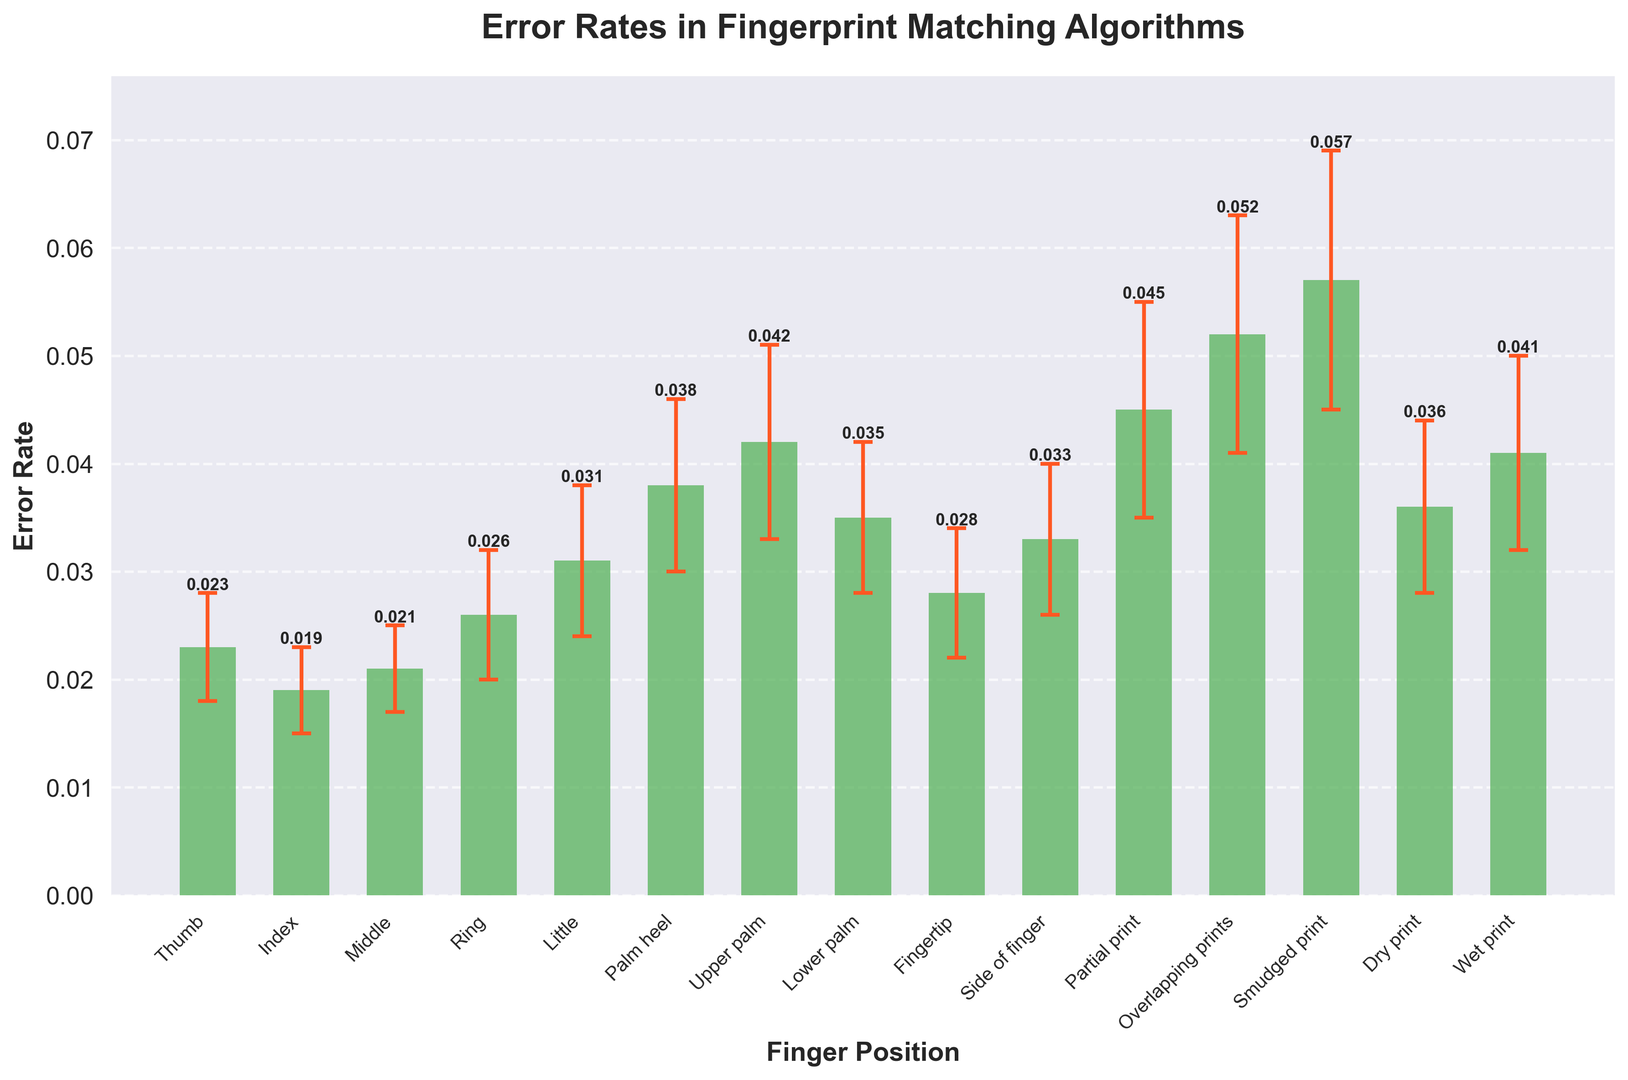Which finger position has the highest error rate? By observing the heights of the bars in the chart, the "Smudged print" bar is the tallest, indicating the highest error rate.
Answer: Smudged print What is the difference in error rate between "Thumb" and "Little" finger positions? The error rate for "Thumb" is 0.023 and for "Little" is 0.031. The difference is calculated as 0.031 - 0.023.
Answer: 0.008 Which finger position has the lowest error rate, and what is its value? By examining the chart, the shortest bar represents the "Index" finger position with an error rate of 0.019.
Answer: Index, 0.019 How much higher is the error rate for "Overlapping prints" compared to "Lower palm"? The error rate for "Overlapping prints" is 0.052 and for "Lower palm" is 0.035. Subtract the error rate of "Lower palm" from "Overlapping prints".
Answer: 0.017 What is the average error rate for the "Thumb", "Index", and "Middle" finger positions? Add the error rates of "Thumb" (0.023), "Index" (0.019), and "Middle" (0.021) and divide by 3: (0.023 + 0.019 + 0.021) / 3.
Answer: 0.021 Which finger positions have error margins greater than or equal to 0.009? By checking the error margin values, "Upper palm" (0.009), "Partial print" (0.010), "Overlapping prints" (0.011), and "Smudged print" (0.012) meet this criterion.
Answer: Upper palm, Partial print, Overlapping prints, Smudged print Identify the finger positions where the error rate exceeds 0.04. Check the bars in the chart that rise above the 0.04 error rate mark; these are "Upper palm", "Partial print", "Overlapping prints", "Smudged print", and "Wet print".
Answer: Upper palm, Partial print, Overlapping prints, Smudged print, Wet print What is the sum of the error rates for the "Palm heel" and "Lower palm" positions? Add the error rates of "Palm heel" (0.038) and "Lower palm" (0.035): 0.038 + 0.035.
Answer: 0.073 Compare the error rates of "Dry print" and "Wet print" and indicate which one is higher. By comparing the heights of the respective bars, "Wet print" has a higher error rate (0.041) compared to "Dry print" (0.036).
Answer: Wet print What is the range of error rates in the chart (highest error rate minus the lowest error rate)? The highest error rate is for "Smudged print" (0.057), and the lowest error rate is for "Index" (0.019). The range is calculated as 0.057 - 0.019.
Answer: 0.038 